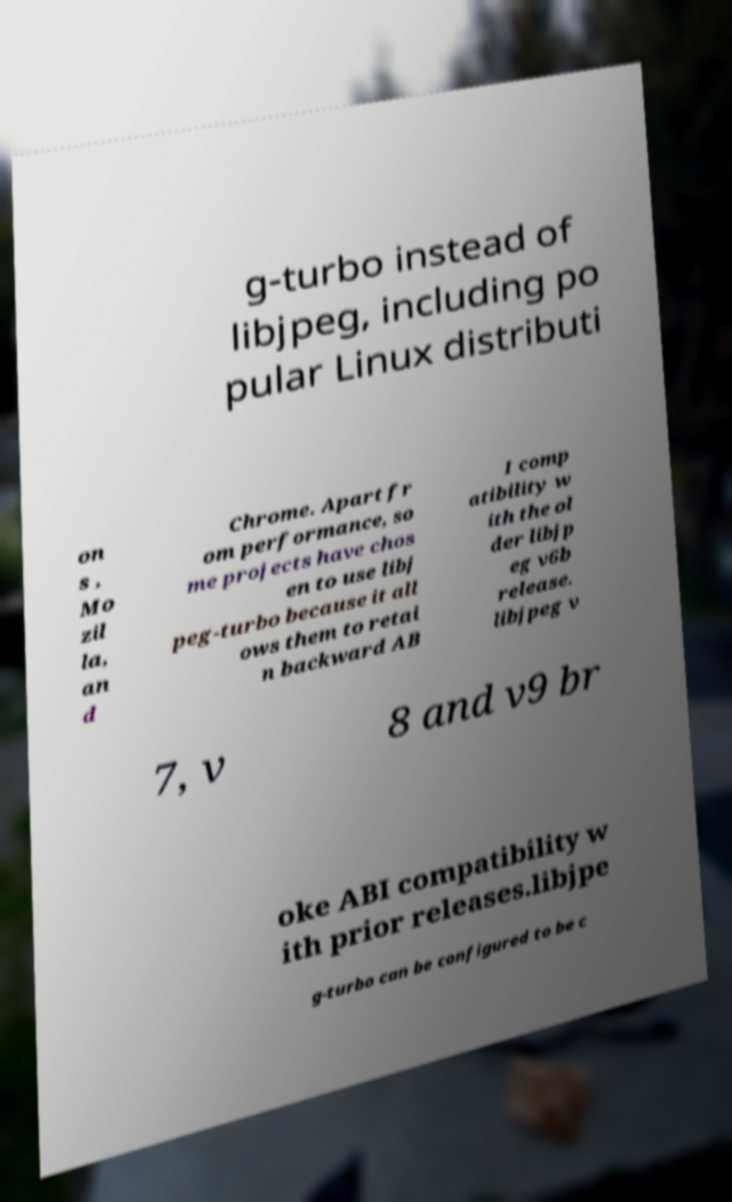Could you extract and type out the text from this image? g-turbo instead of libjpeg, including po pular Linux distributi on s , Mo zil la, an d Chrome. Apart fr om performance, so me projects have chos en to use libj peg-turbo because it all ows them to retai n backward AB I comp atibility w ith the ol der libjp eg v6b release. libjpeg v 7, v 8 and v9 br oke ABI compatibility w ith prior releases.libjpe g-turbo can be configured to be c 